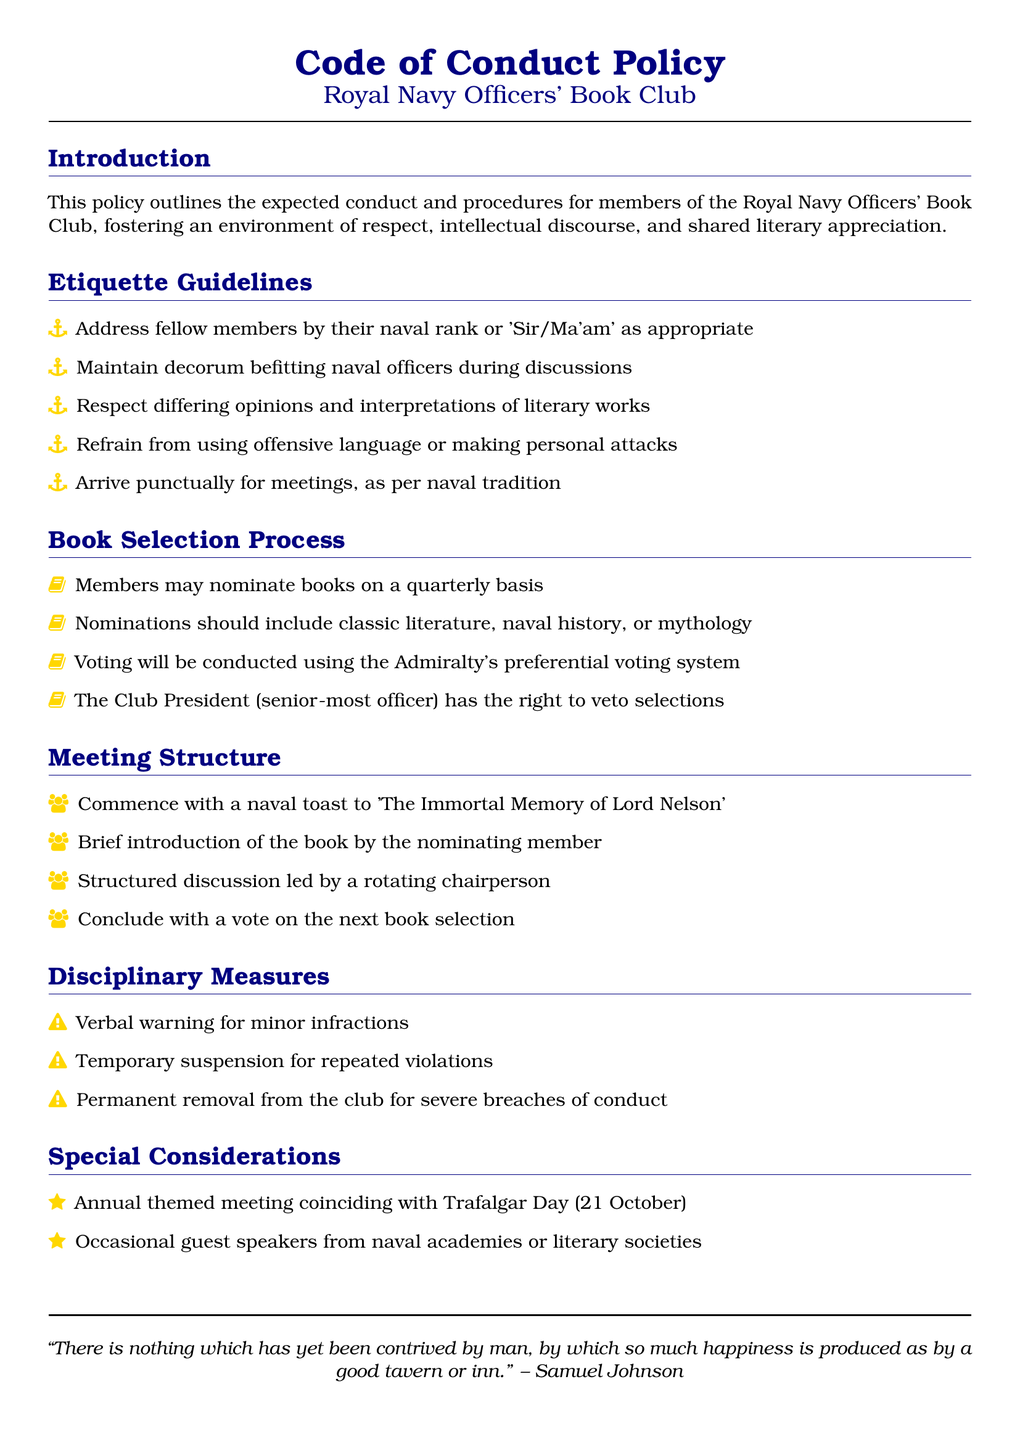What is the title of the policy document? The title given in the document is the official title for the guidelines set forth within it.
Answer: Code of Conduct Policy Who should member's address each other as? This is mentioned in the etiquette guidelines, indicating how members should greet one another according to naval tradition.
Answer: Naval rank or 'Sir/Ma'am' How often can members nominate books? This detail indicates how frequently members have the opportunity to introduce new reading selections to the club.
Answer: Quarterly What is the primary focus of the book nominations? This specifies the types of literature that members are encouraged to consider for their nominations.
Answer: Classic literature, naval history, or mythology What is the consequence of a severe breach of conduct? This refers to the most serious disciplinary action outlined for violations of the code of conduct.
Answer: Permanent removal from the club What special event coincides with the annual meeting? This indicates a significant date that is celebrated within the club, adding a commemorative aspect to their activities.
Answer: Trafalgar Day (21 October) Who leads the structured discussion during meetings? This specifies the role of individuals in facilitating discussions based on the members' nominations.
Answer: A rotating chairperson What type of toast is commenced at the meetings? This reflects the tradition they uphold at the start of their gatherings, linking to naval history.
Answer: A naval toast to 'The Immortal Memory of Lord Nelson' What is the voting system to be used for book selection? This indicates the specific method adopted by the club for making collective decisions regarding book selections.
Answer: The Admiralty's preferential voting system 